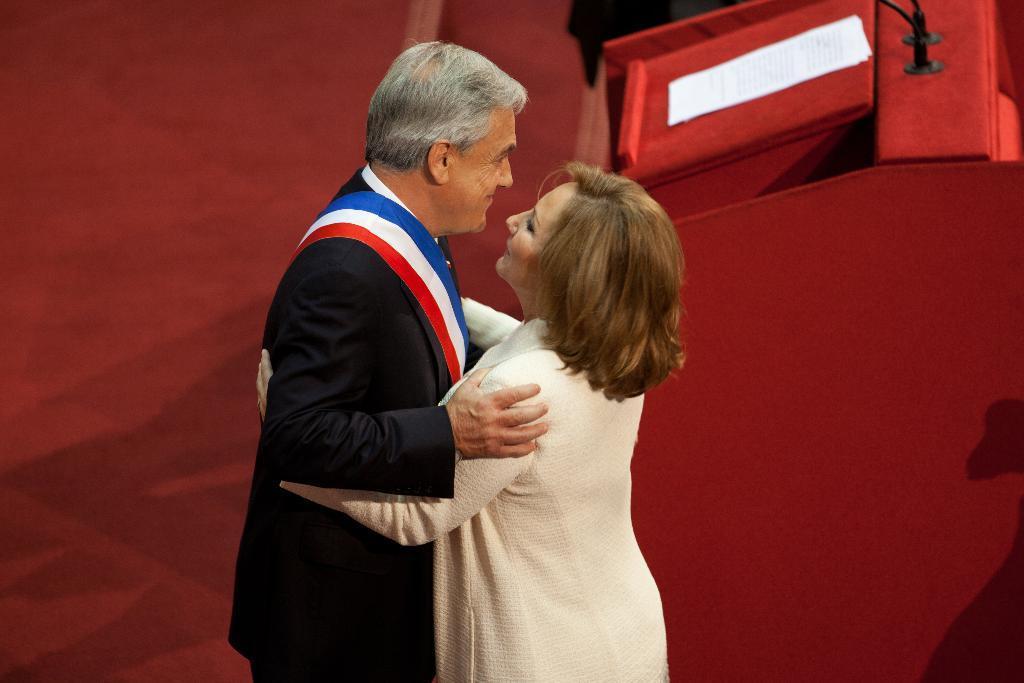Can you describe this image briefly? In the image there is a man and a lady standing and facing each other. On the man there is a cloth which is in red, white and blue color. There is a red color background. And also there is a podium with papers and mic stands. 